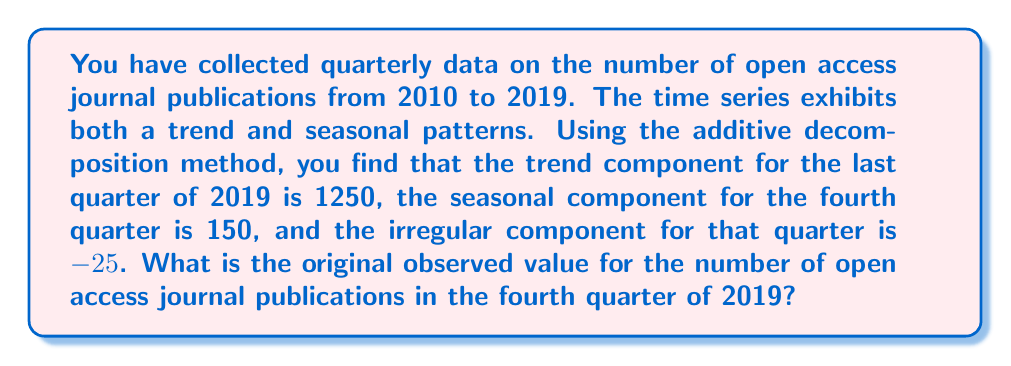Teach me how to tackle this problem. To solve this problem, we need to understand the additive decomposition method for time series analysis. In this method, a time series $Y_t$ is decomposed into three components:

1. Trend component ($T_t$)
2. Seasonal component ($S_t$)
3. Irregular component ($I_t$)

The additive model is represented as:

$$Y_t = T_t + S_t + I_t$$

Where:
$Y_t$ is the observed value at time t
$T_t$ is the trend component at time t
$S_t$ is the seasonal component at time t
$I_t$ is the irregular component at time t

Given:
- Trend component for Q4 2019: $T_t = 1250$
- Seasonal component for Q4: $S_t = 150$
- Irregular component for Q4 2019: $I_t = -25$

To find the original observed value, we simply need to add these components:

$$Y_t = T_t + S_t + I_t$$
$$Y_t = 1250 + 150 + (-25)$$
$$Y_t = 1250 + 150 - 25$$
$$Y_t = 1375$$

Therefore, the original observed value for the number of open access journal publications in the fourth quarter of 2019 is 1375.
Answer: 1375 open access journal publications 